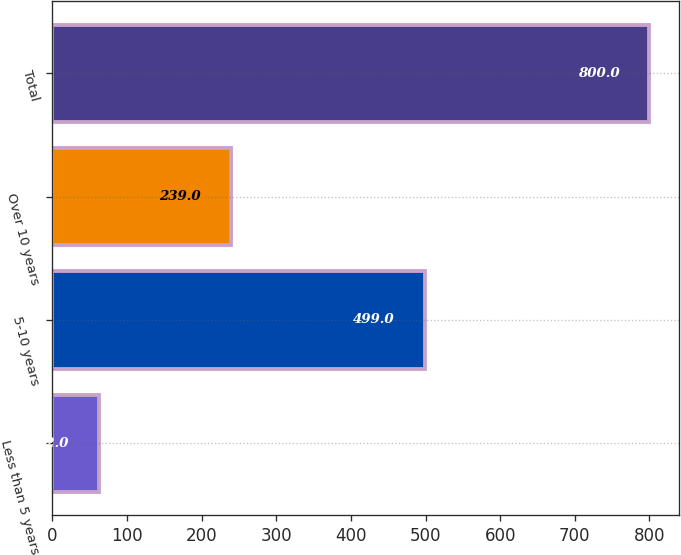Convert chart to OTSL. <chart><loc_0><loc_0><loc_500><loc_500><bar_chart><fcel>Less than 5 years<fcel>5-10 years<fcel>Over 10 years<fcel>Total<nl><fcel>62<fcel>499<fcel>239<fcel>800<nl></chart> 